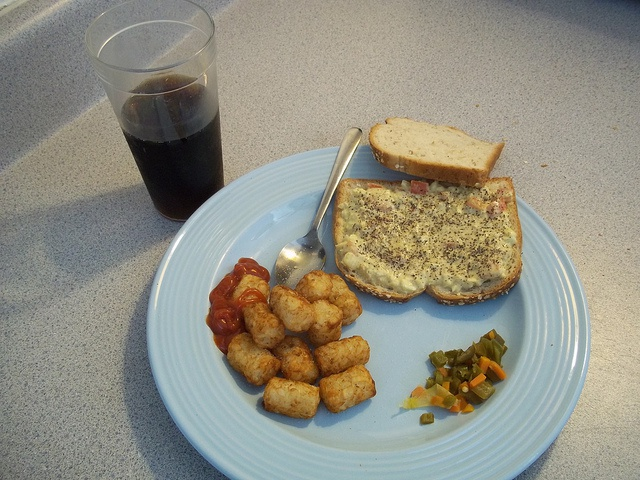Describe the objects in this image and their specific colors. I can see dining table in darkgray, gray, and tan tones, sandwich in darkgray, tan, and olive tones, cup in darkgray, black, and gray tones, and spoon in darkgray, tan, and gray tones in this image. 